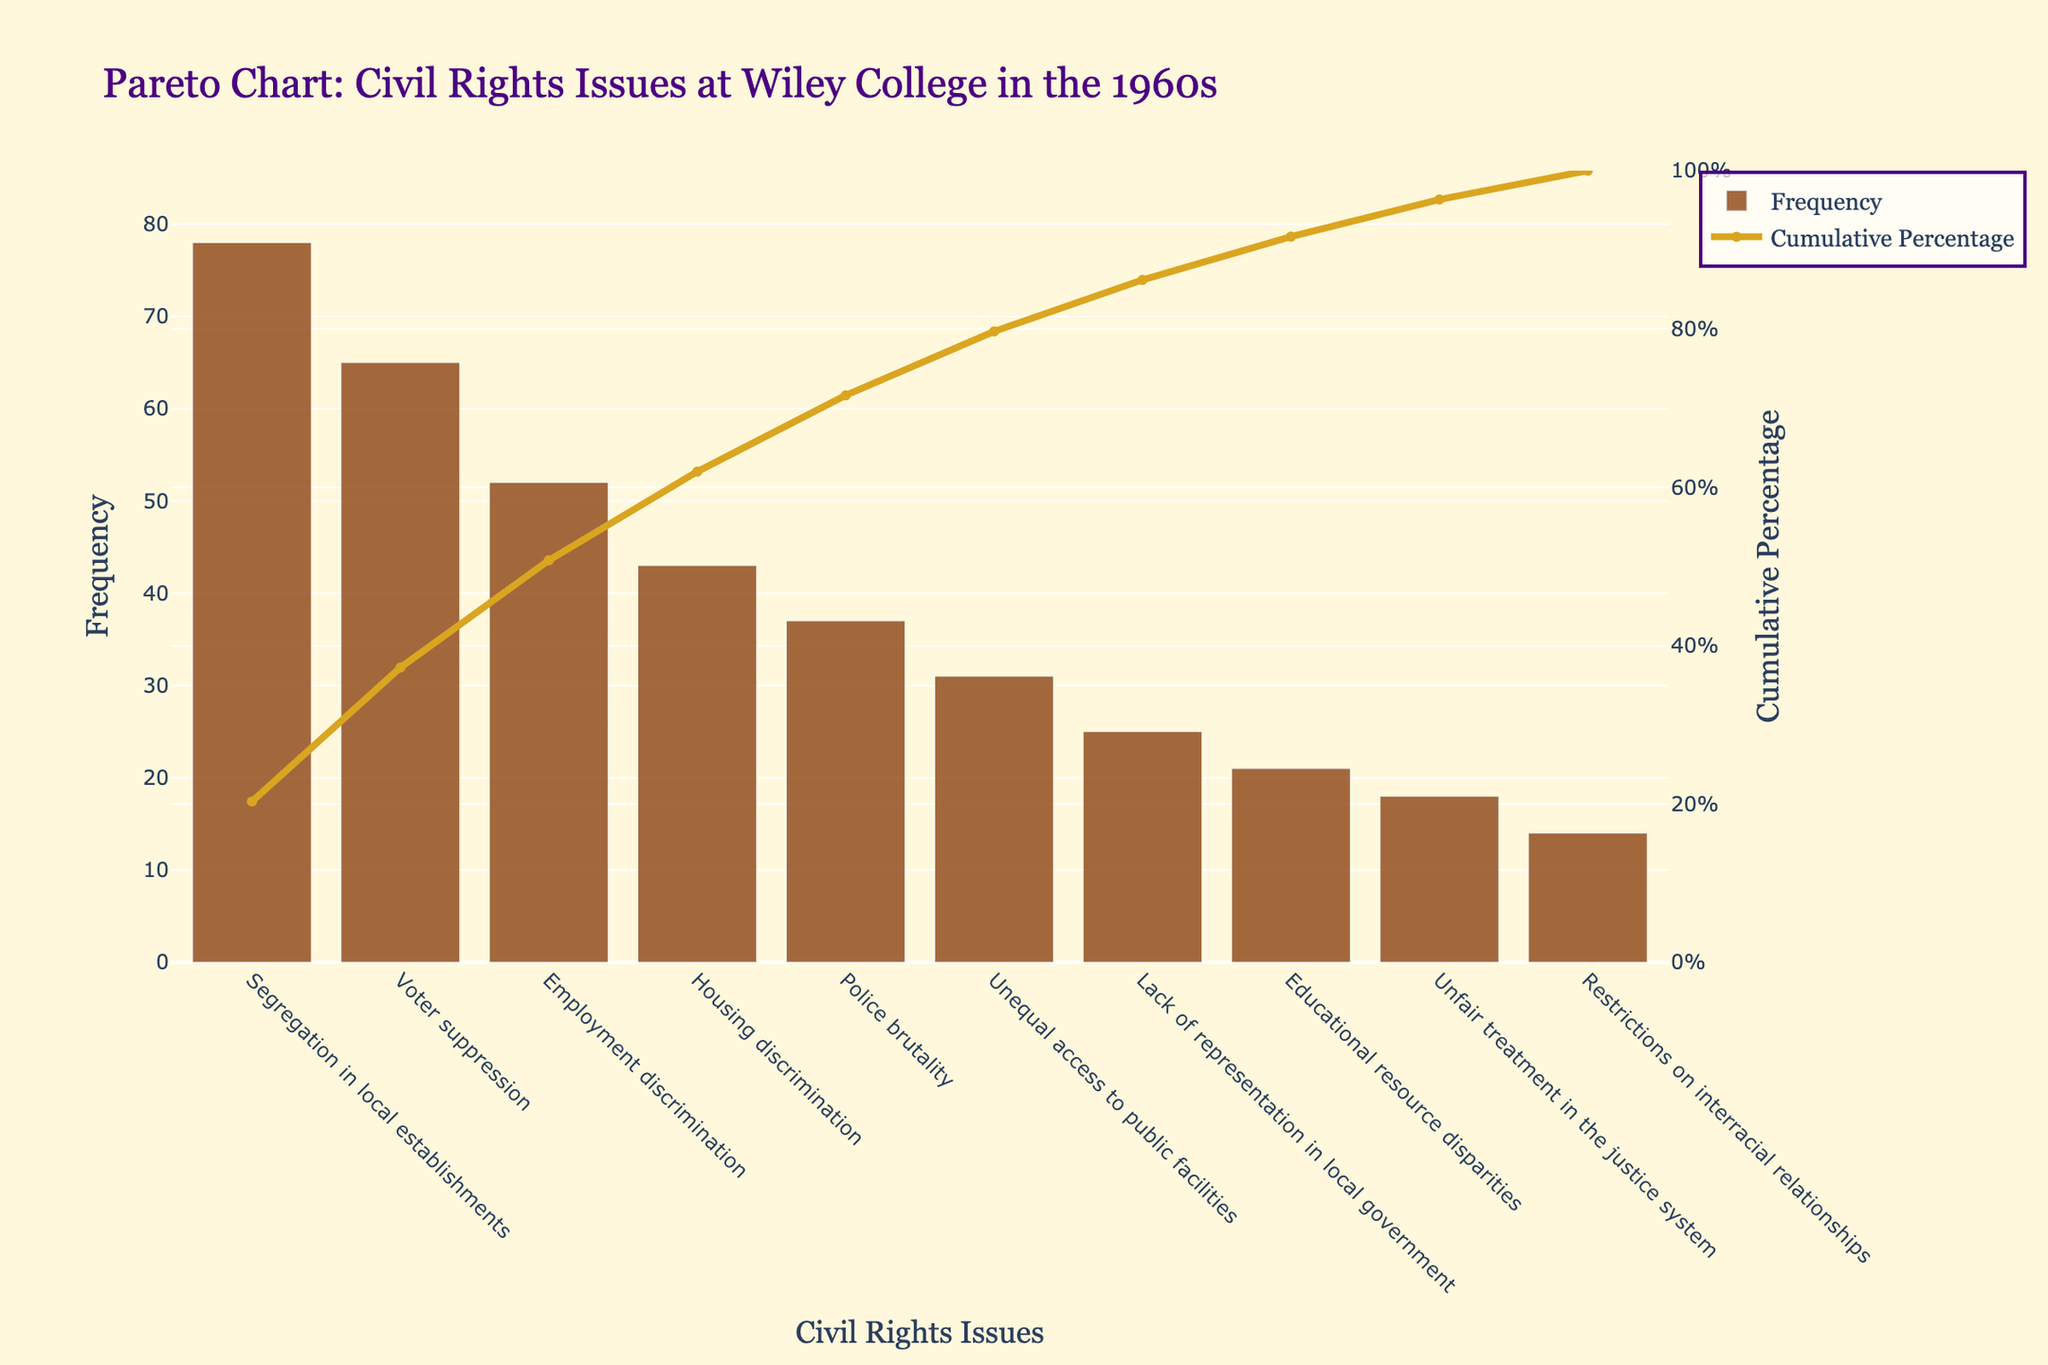How many civil rights issues are highlighted in the Pareto chart? Count the number of bars representing different civil rights issues in the chart.
Answer: 10 What is the most common civil rights issue faced by students at Wiley College in the 1960s? Identify the issue with the highest bar on the chart.
Answer: Segregation in local establishments What's the cumulative percentage of the top three most common civil rights issues? Add the cumulative percentages of the first three bars.
Answer: 54.5% Which issue has the lowest frequency in the chart? Identify the issue with the smallest bar height.
Answer: Restrictions on interracial relationships What cumulative percentage does 'Police brutality' contribute to? Find the cumulative percentage value corresponding to the 'Police brutality' bar.
Answer: 82.7% How does 'Housing discrimination' compare to 'Employment discrimination' in terms of frequency? Compare the heights of the bars for 'Housing discrimination' and 'Employment discrimination'.
Answer: Housing discrimination is less frequent By what percentage does the cumulative line reach 100%? Cumulative lines in Pareto charts are designed to reach 100%, representing the totality of the issues.
Answer: 100% Which issue contributes to a cumulative percentage just above 50%? Find the issue where the cumulative percentage first exceeds 50%.
Answer: Employment discrimination 